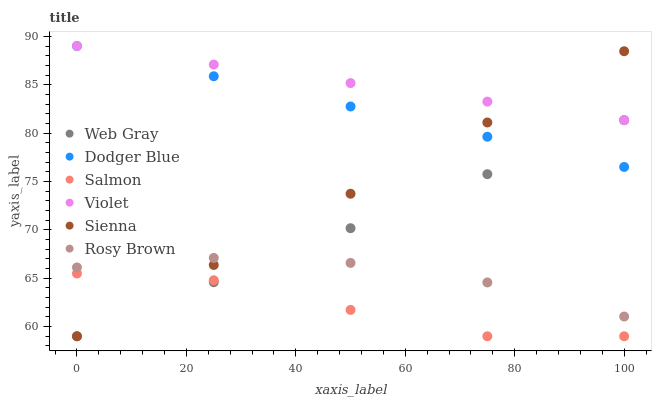Does Salmon have the minimum area under the curve?
Answer yes or no. Yes. Does Violet have the maximum area under the curve?
Answer yes or no. Yes. Does Rosy Brown have the minimum area under the curve?
Answer yes or no. No. Does Rosy Brown have the maximum area under the curve?
Answer yes or no. No. Is Web Gray the smoothest?
Answer yes or no. Yes. Is Salmon the roughest?
Answer yes or no. Yes. Is Rosy Brown the smoothest?
Answer yes or no. No. Is Rosy Brown the roughest?
Answer yes or no. No. Does Web Gray have the lowest value?
Answer yes or no. Yes. Does Rosy Brown have the lowest value?
Answer yes or no. No. Does Violet have the highest value?
Answer yes or no. Yes. Does Rosy Brown have the highest value?
Answer yes or no. No. Is Salmon less than Rosy Brown?
Answer yes or no. Yes. Is Violet greater than Rosy Brown?
Answer yes or no. Yes. Does Web Gray intersect Salmon?
Answer yes or no. Yes. Is Web Gray less than Salmon?
Answer yes or no. No. Is Web Gray greater than Salmon?
Answer yes or no. No. Does Salmon intersect Rosy Brown?
Answer yes or no. No. 